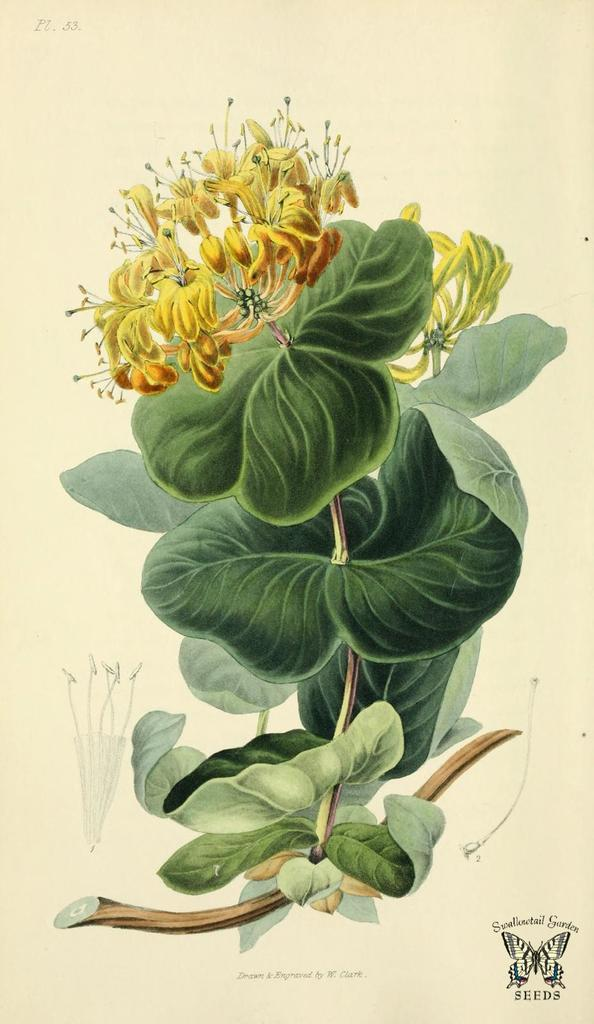What is the main subject of the image? The image contains an art piece. What does the art piece depict? The art piece depicts leaves and flowers of a plant. Can you describe any additional elements in the art piece? Yes, there is a butterfly symbol at the right bottom of the art piece. Is there any text present in the art piece? Yes, there is some text present in the art piece. How many times does the grandfather kiss the ring in the image? There is no grandfather, kiss, or ring present in the image. 